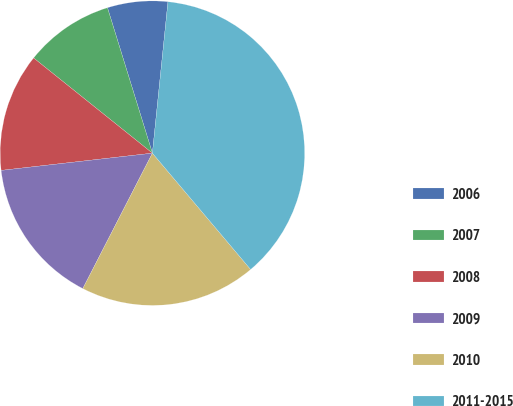Convert chart. <chart><loc_0><loc_0><loc_500><loc_500><pie_chart><fcel>2006<fcel>2007<fcel>2008<fcel>2009<fcel>2010<fcel>2011-2015<nl><fcel>6.4%<fcel>9.48%<fcel>12.56%<fcel>15.64%<fcel>18.72%<fcel>37.21%<nl></chart> 